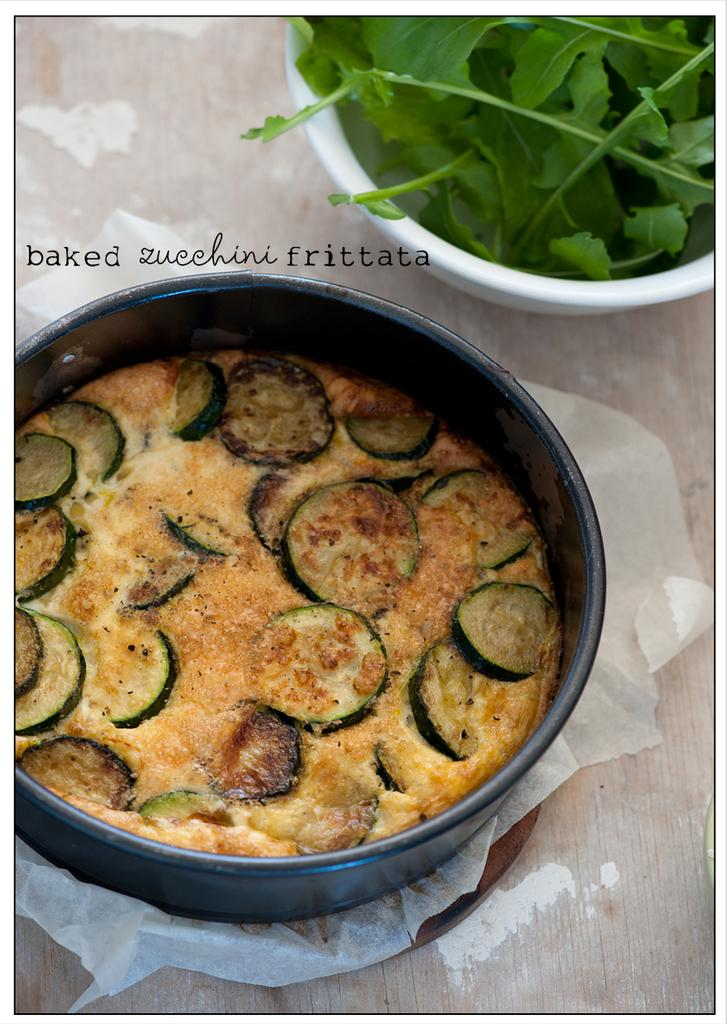What type of food can be seen in the image? The food in the image includes bowls. What else is present in the image besides the food? There are balls in the image. What is the color of the balls? The balls are in black and white color. What is the color of the food? The food is in brown and green color. What is the surface on which the food and balls are placed? The food and balls are on a wooden surface. What type of discovery was made in the mine in the image? There is no mine or discovery present in the image; it features food and balls on a wooden surface. 